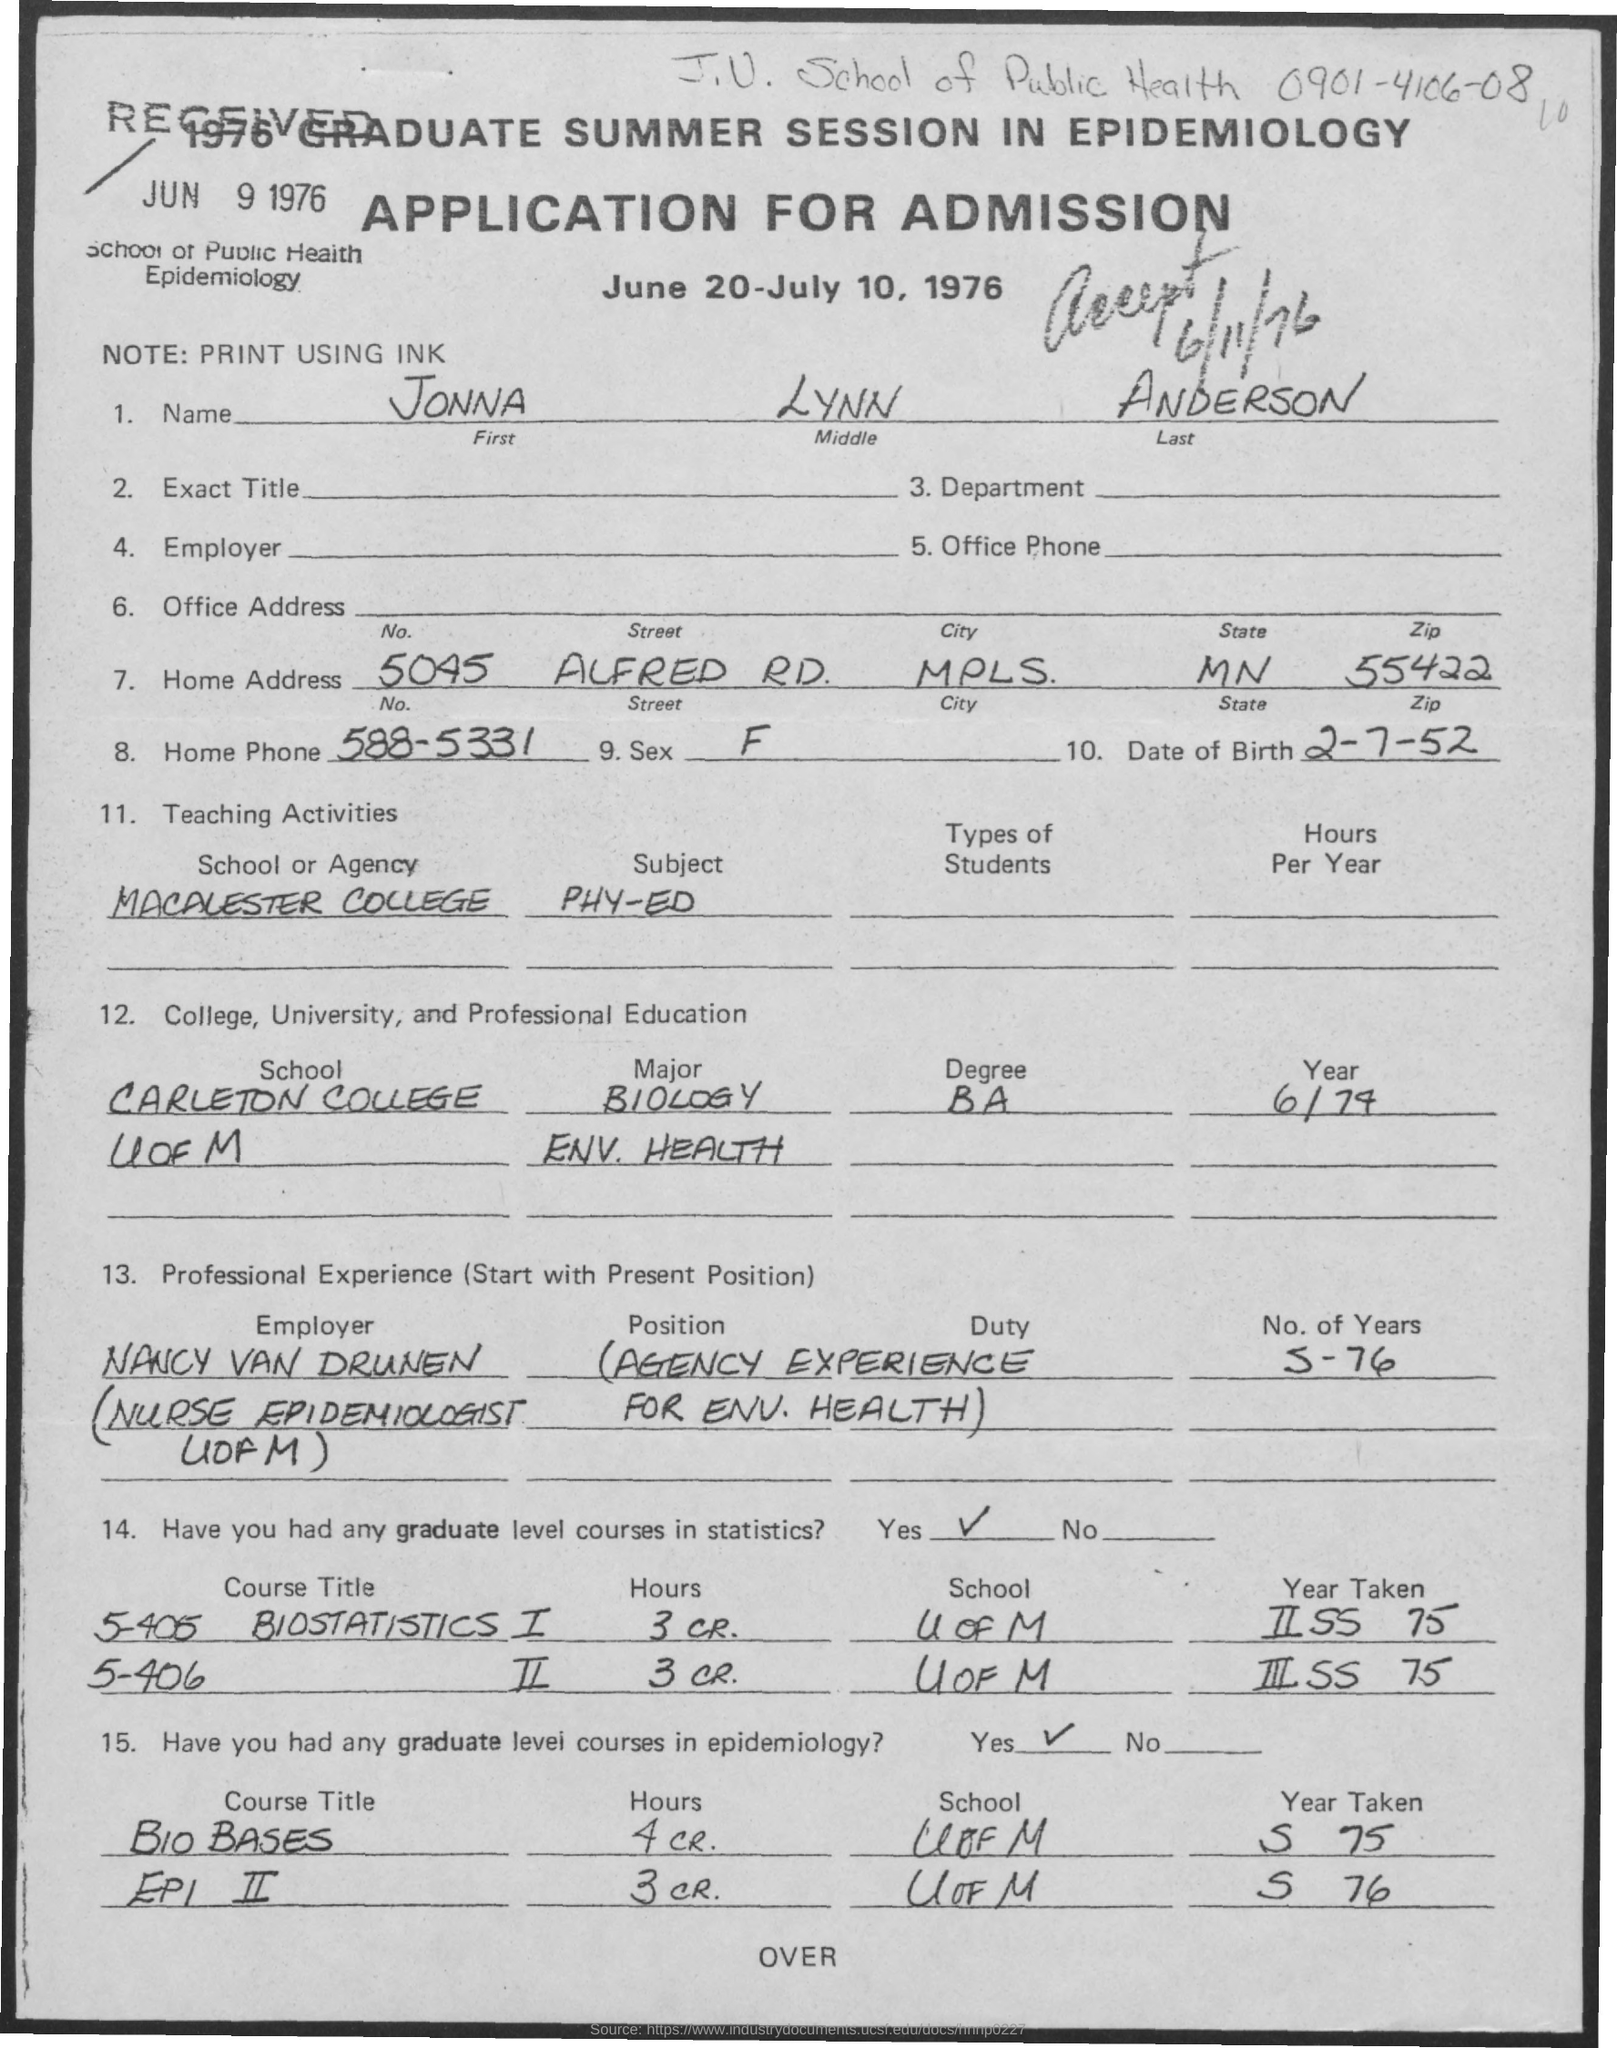What is the First Name?
Offer a very short reply. JONNA. What is the Middle Name?
Provide a short and direct response. Lynn. What is the Last Name?
Provide a short and direct response. Anderson. What is the Home Phone?
Ensure brevity in your answer.  588-5331. What is the Date of Birth?
Provide a short and direct response. 2-7-52. What is the Sex?
Provide a short and direct response. F. 